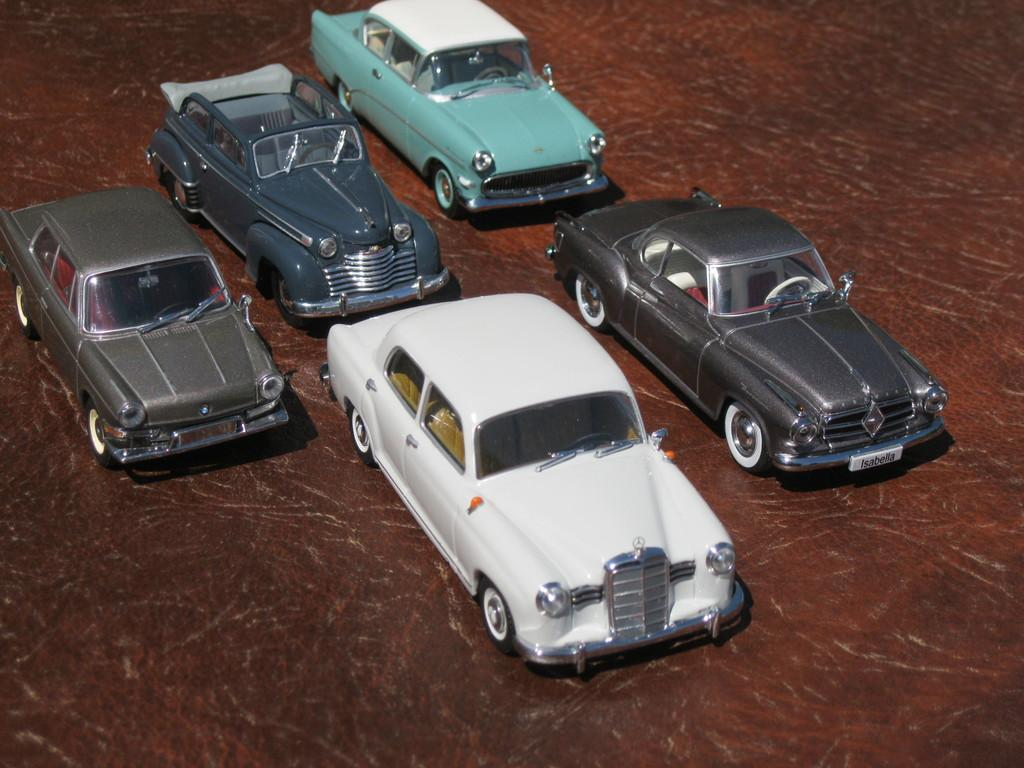What types of objects are present in the image? There are vehicles in the image. Can you describe the colors of the vehicles? The vehicles have white, gray, and green colors. How many tomatoes are being digested by the vehicles in the image? There are no tomatoes present in the image, and vehicles do not have the ability to digest anything. 